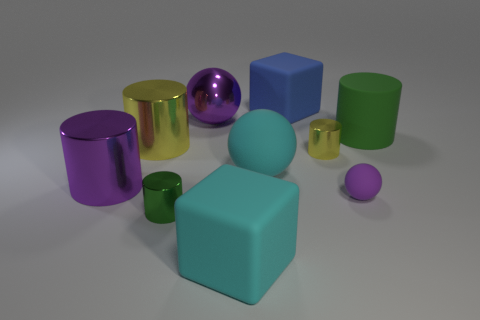Are there fewer big cyan objects than large purple matte cylinders?
Ensure brevity in your answer.  No. How big is the cylinder that is in front of the green rubber cylinder and right of the tiny green object?
Give a very brief answer. Small. Is the color of the block in front of the big yellow cylinder the same as the metallic sphere?
Your answer should be compact. No. Is the number of large rubber things to the right of the big cyan rubber block less than the number of red metal blocks?
Your response must be concise. No. What is the shape of the green thing that is made of the same material as the small purple sphere?
Your answer should be compact. Cylinder. Is the large green cylinder made of the same material as the cyan block?
Your answer should be compact. Yes. Are there fewer shiny balls that are in front of the purple matte sphere than yellow cylinders that are to the right of the small green metal object?
Provide a succinct answer. Yes. There is a metal object that is the same color as the big shiny sphere; what size is it?
Ensure brevity in your answer.  Large. There is a metallic cylinder that is in front of the purple metal object in front of the green matte cylinder; how many tiny yellow metal objects are on the left side of it?
Provide a succinct answer. 0. Do the large metal sphere and the rubber cylinder have the same color?
Give a very brief answer. No. 